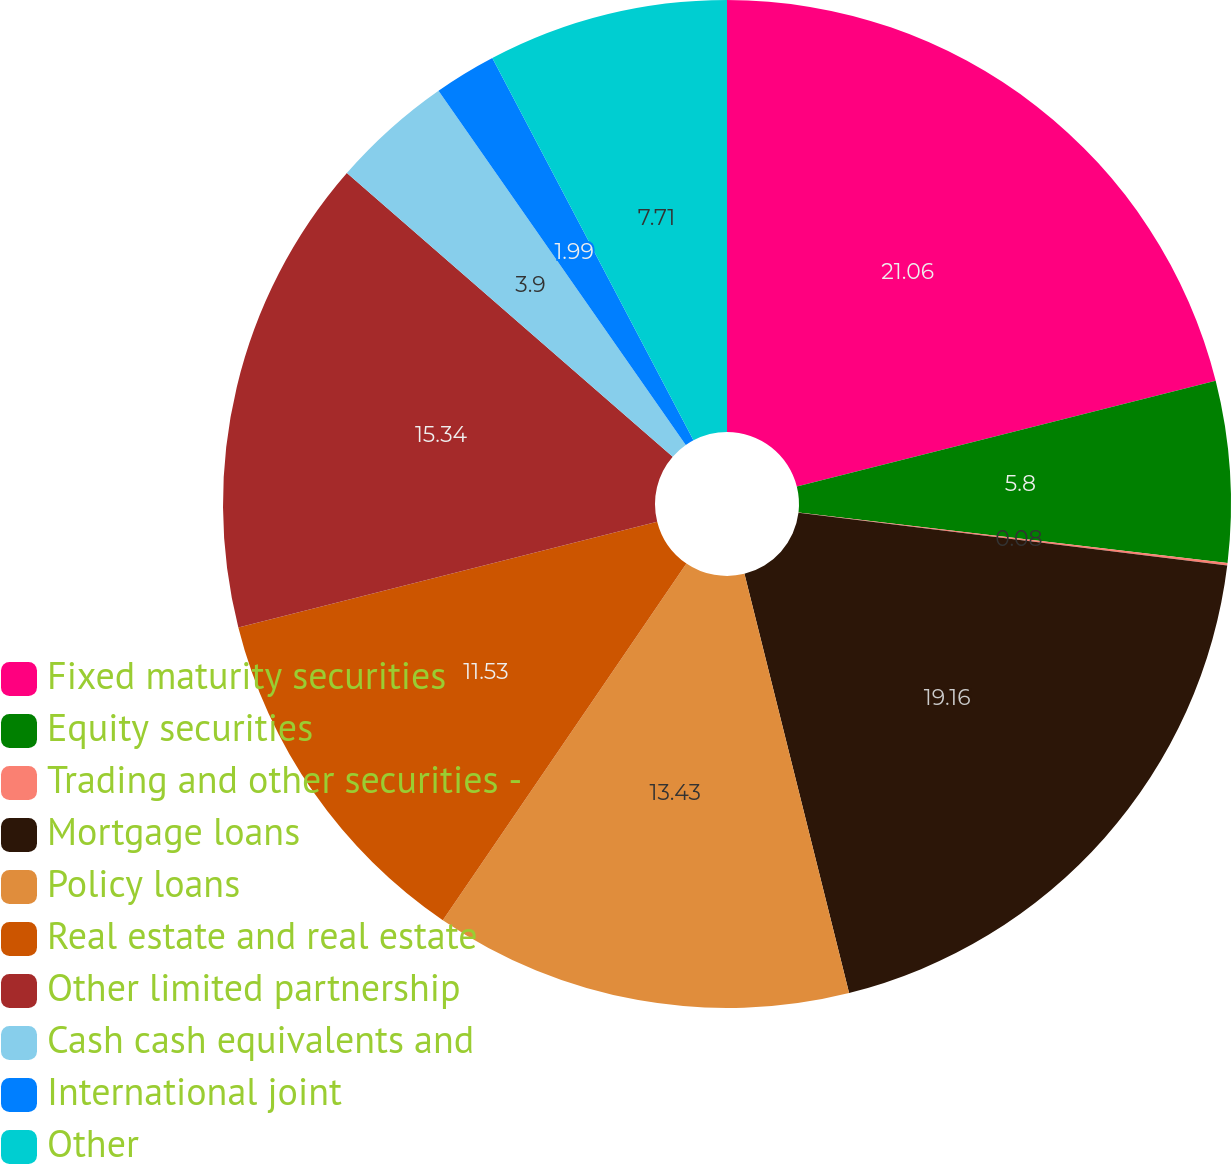Convert chart. <chart><loc_0><loc_0><loc_500><loc_500><pie_chart><fcel>Fixed maturity securities<fcel>Equity securities<fcel>Trading and other securities -<fcel>Mortgage loans<fcel>Policy loans<fcel>Real estate and real estate<fcel>Other limited partnership<fcel>Cash cash equivalents and<fcel>International joint<fcel>Other<nl><fcel>21.07%<fcel>5.8%<fcel>0.08%<fcel>19.16%<fcel>13.43%<fcel>11.53%<fcel>15.34%<fcel>3.9%<fcel>1.99%<fcel>7.71%<nl></chart> 